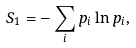<formula> <loc_0><loc_0><loc_500><loc_500>S _ { 1 } = - \sum _ { i } p _ { i } \ln p _ { i } ,</formula> 